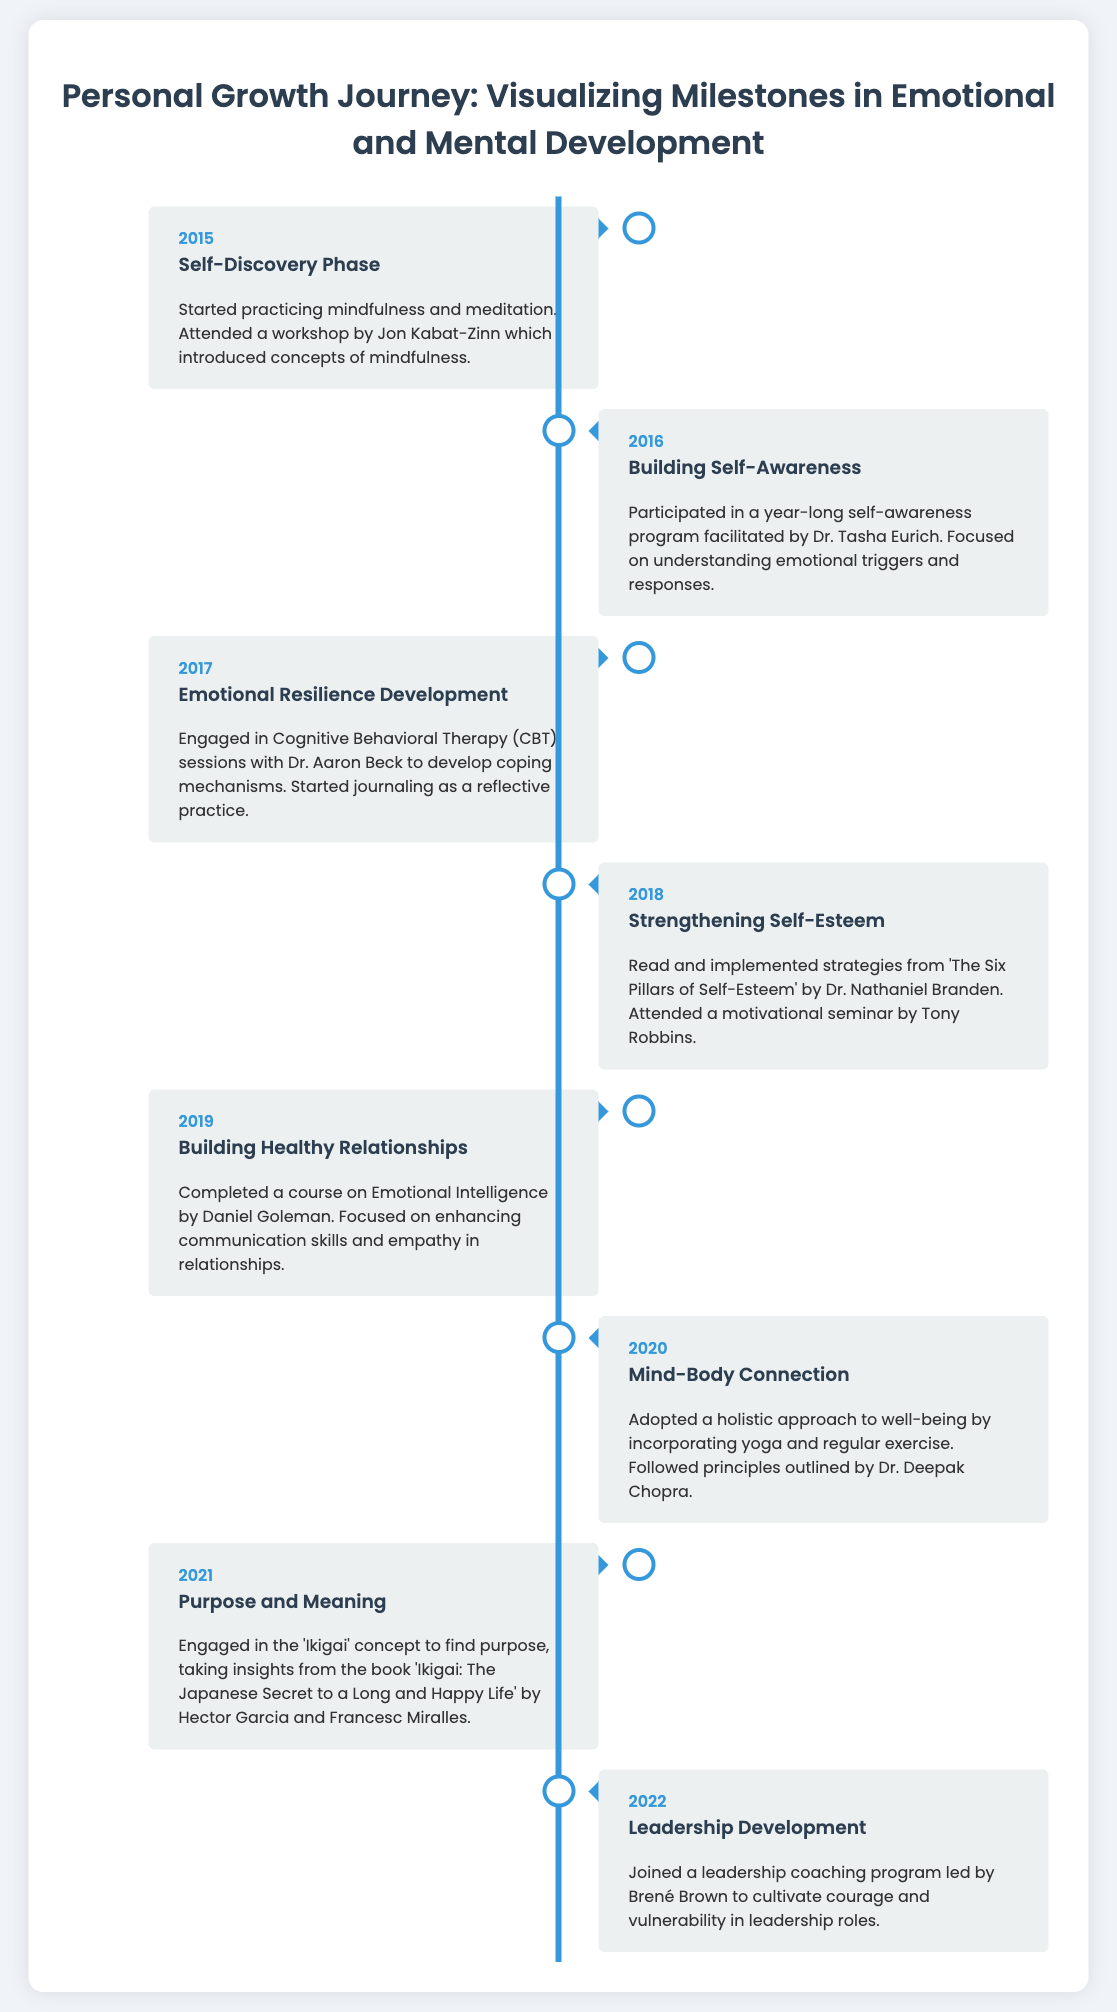what year did the self-discovery phase begin? The self-discovery phase started in 2015, as indicated in the timeline.
Answer: 2015 who facilitated the self-awareness program in 2016? Dr. Tasha Eurich facilitated the self-awareness program mentioned for 2016.
Answer: Dr. Tasha Eurich what therapeutic method was used for emotional resilience development? Cognitive Behavioral Therapy (CBT) was the method used for emotional resilience development specified in 2017.
Answer: Cognitive Behavioral Therapy (CBT) which book influenced the strengthening of self-esteem in 2018? 'The Six Pillars of Self-Esteem' by Dr. Nathaniel Branden is the book that influenced self-esteem strengthening in 2018.
Answer: 'The Six Pillars of Self-Esteem' what concept was explored in 2021 to find purpose? The 'Ikigai' concept was explored to find purpose in 2021.
Answer: 'Ikigai' which program did Brené Brown lead in 2022? Brené Brown led a leadership coaching program in 2022, as stated in the timeline.
Answer: leadership coaching program how many milestones are listed in the timeline? The timeline lists a total of eight milestones in personal growth.
Answer: eight what year focused on building healthy relationships? The timeline indicates that building healthy relationships was the focus in 2019.
Answer: 2019 